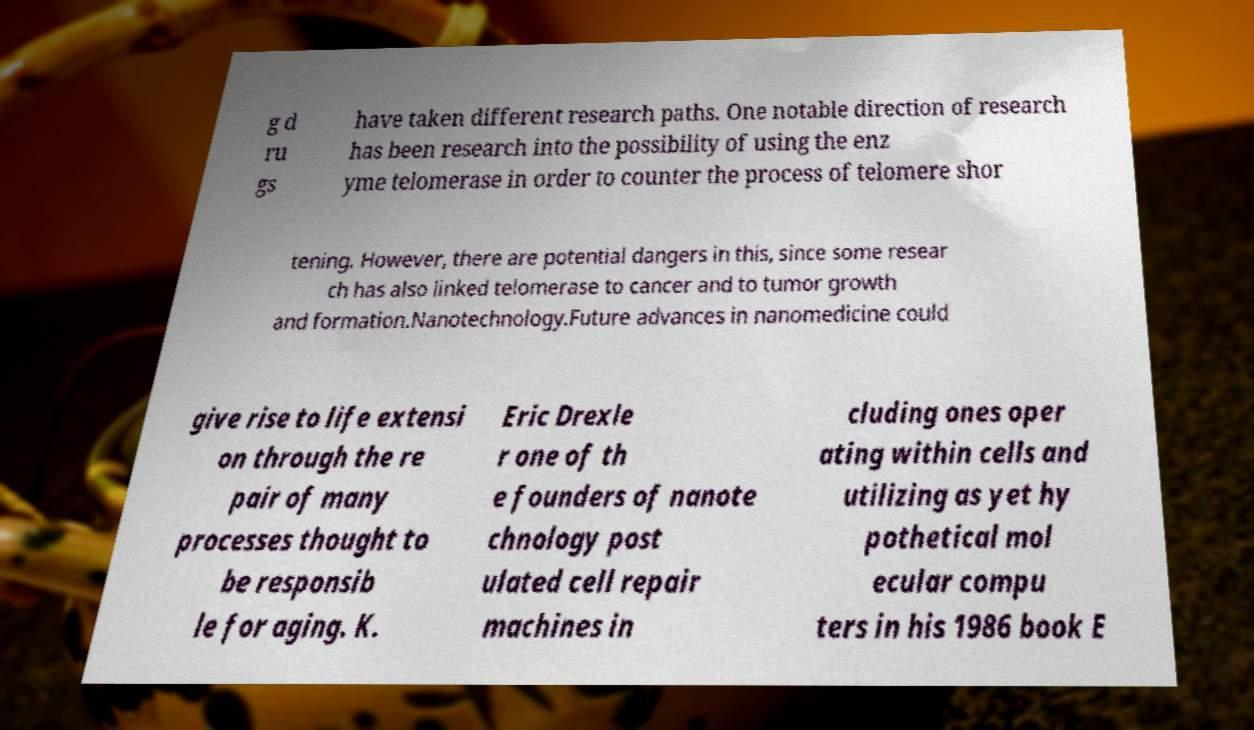For documentation purposes, I need the text within this image transcribed. Could you provide that? g d ru gs have taken different research paths. One notable direction of research has been research into the possibility of using the enz yme telomerase in order to counter the process of telomere shor tening. However, there are potential dangers in this, since some resear ch has also linked telomerase to cancer and to tumor growth and formation.Nanotechnology.Future advances in nanomedicine could give rise to life extensi on through the re pair of many processes thought to be responsib le for aging. K. Eric Drexle r one of th e founders of nanote chnology post ulated cell repair machines in cluding ones oper ating within cells and utilizing as yet hy pothetical mol ecular compu ters in his 1986 book E 